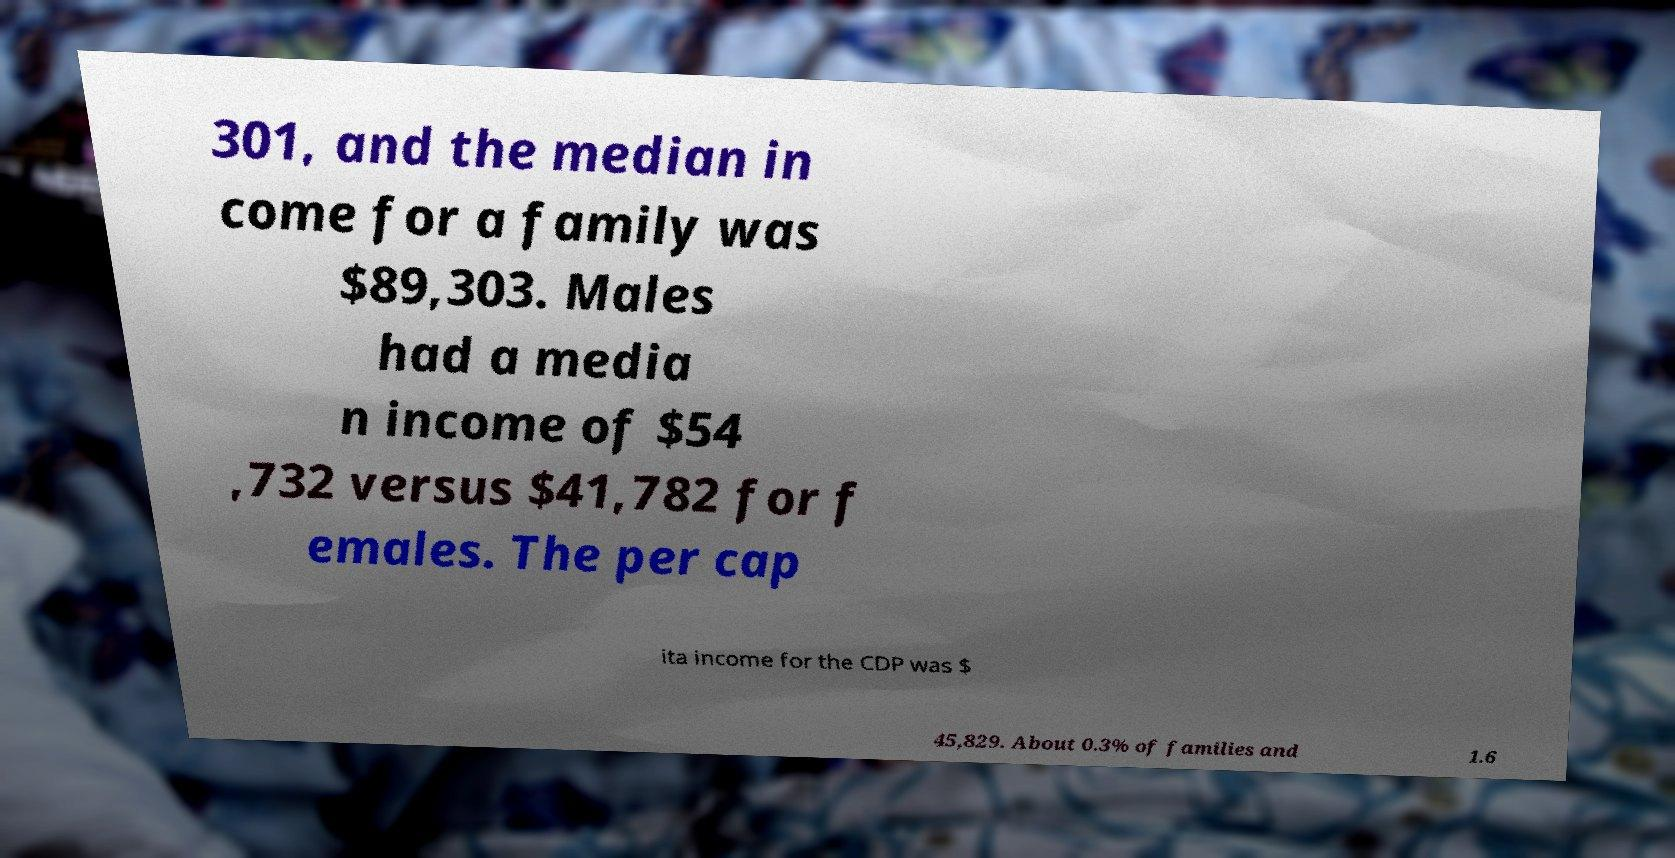I need the written content from this picture converted into text. Can you do that? 301, and the median in come for a family was $89,303. Males had a media n income of $54 ,732 versus $41,782 for f emales. The per cap ita income for the CDP was $ 45,829. About 0.3% of families and 1.6 